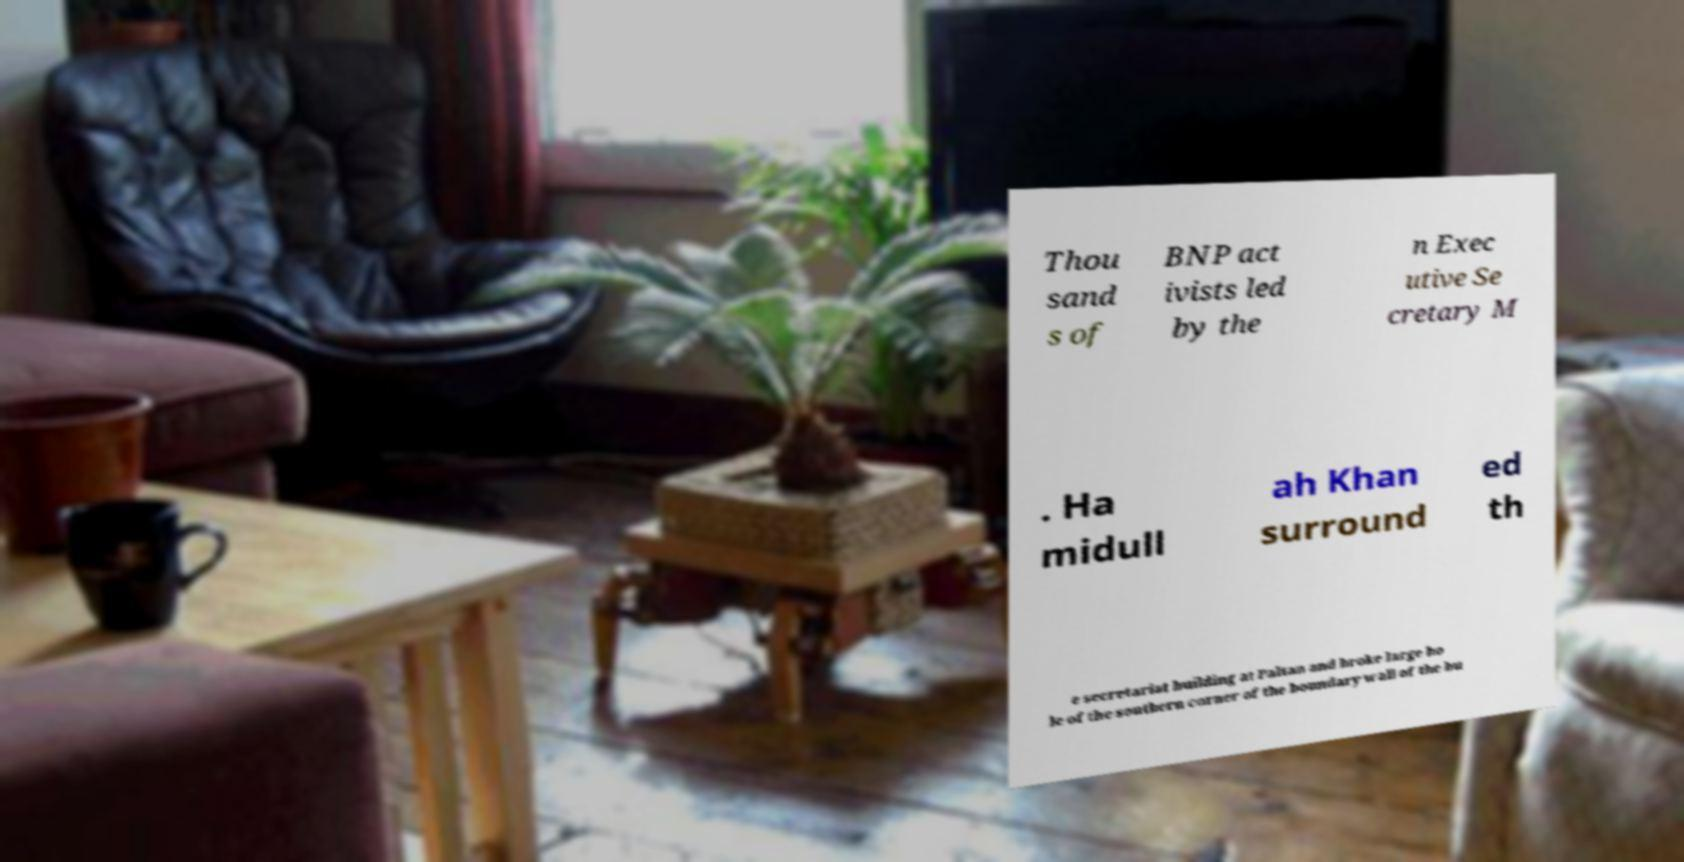Please identify and transcribe the text found in this image. Thou sand s of BNP act ivists led by the n Exec utive Se cretary M . Ha midull ah Khan surround ed th e secretariat building at Paltan and broke large ho le of the southern corner of the boundary wall of the bu 